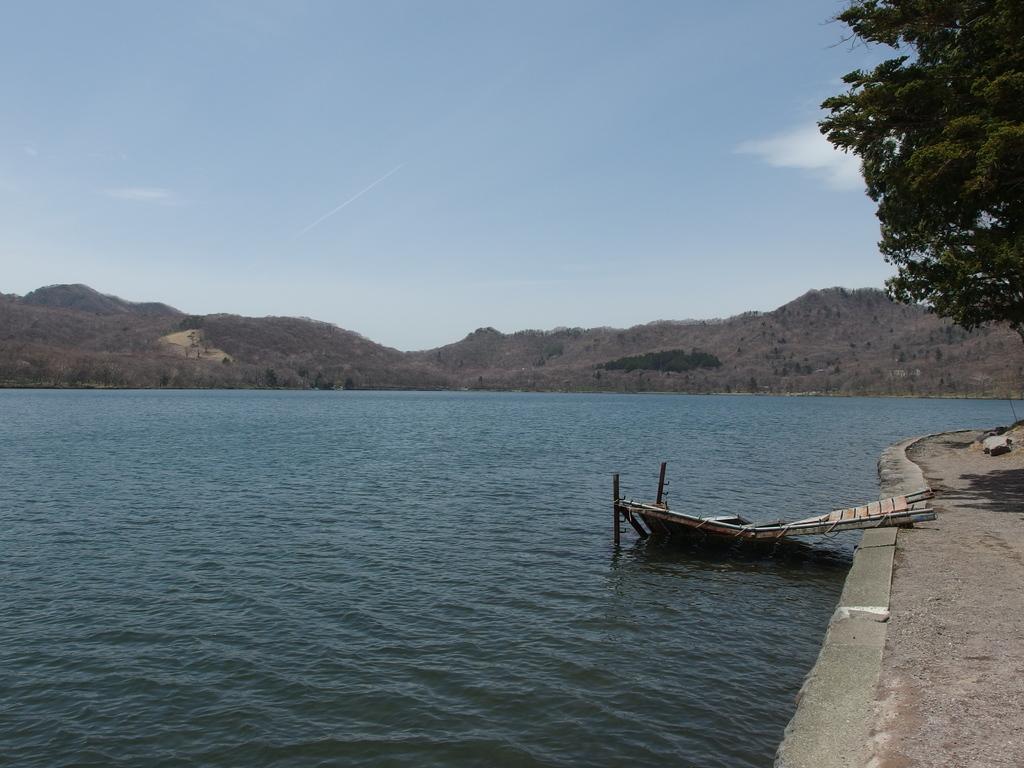Can you describe this image briefly? In this image we can see the water and a wooden object. Behind the water we can see the mountains. On the right side, we can see the walkway and a tree. At the top we can see the sky. 